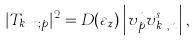Convert formula to latex. <formula><loc_0><loc_0><loc_500><loc_500>| T _ { k _ { z } n ; p } | ^ { 2 } = D ( \varepsilon _ { z } ) \left | v _ { p } ^ { n } v { _ { k _ { z } , n } ^ { s } } \right | ,</formula> 